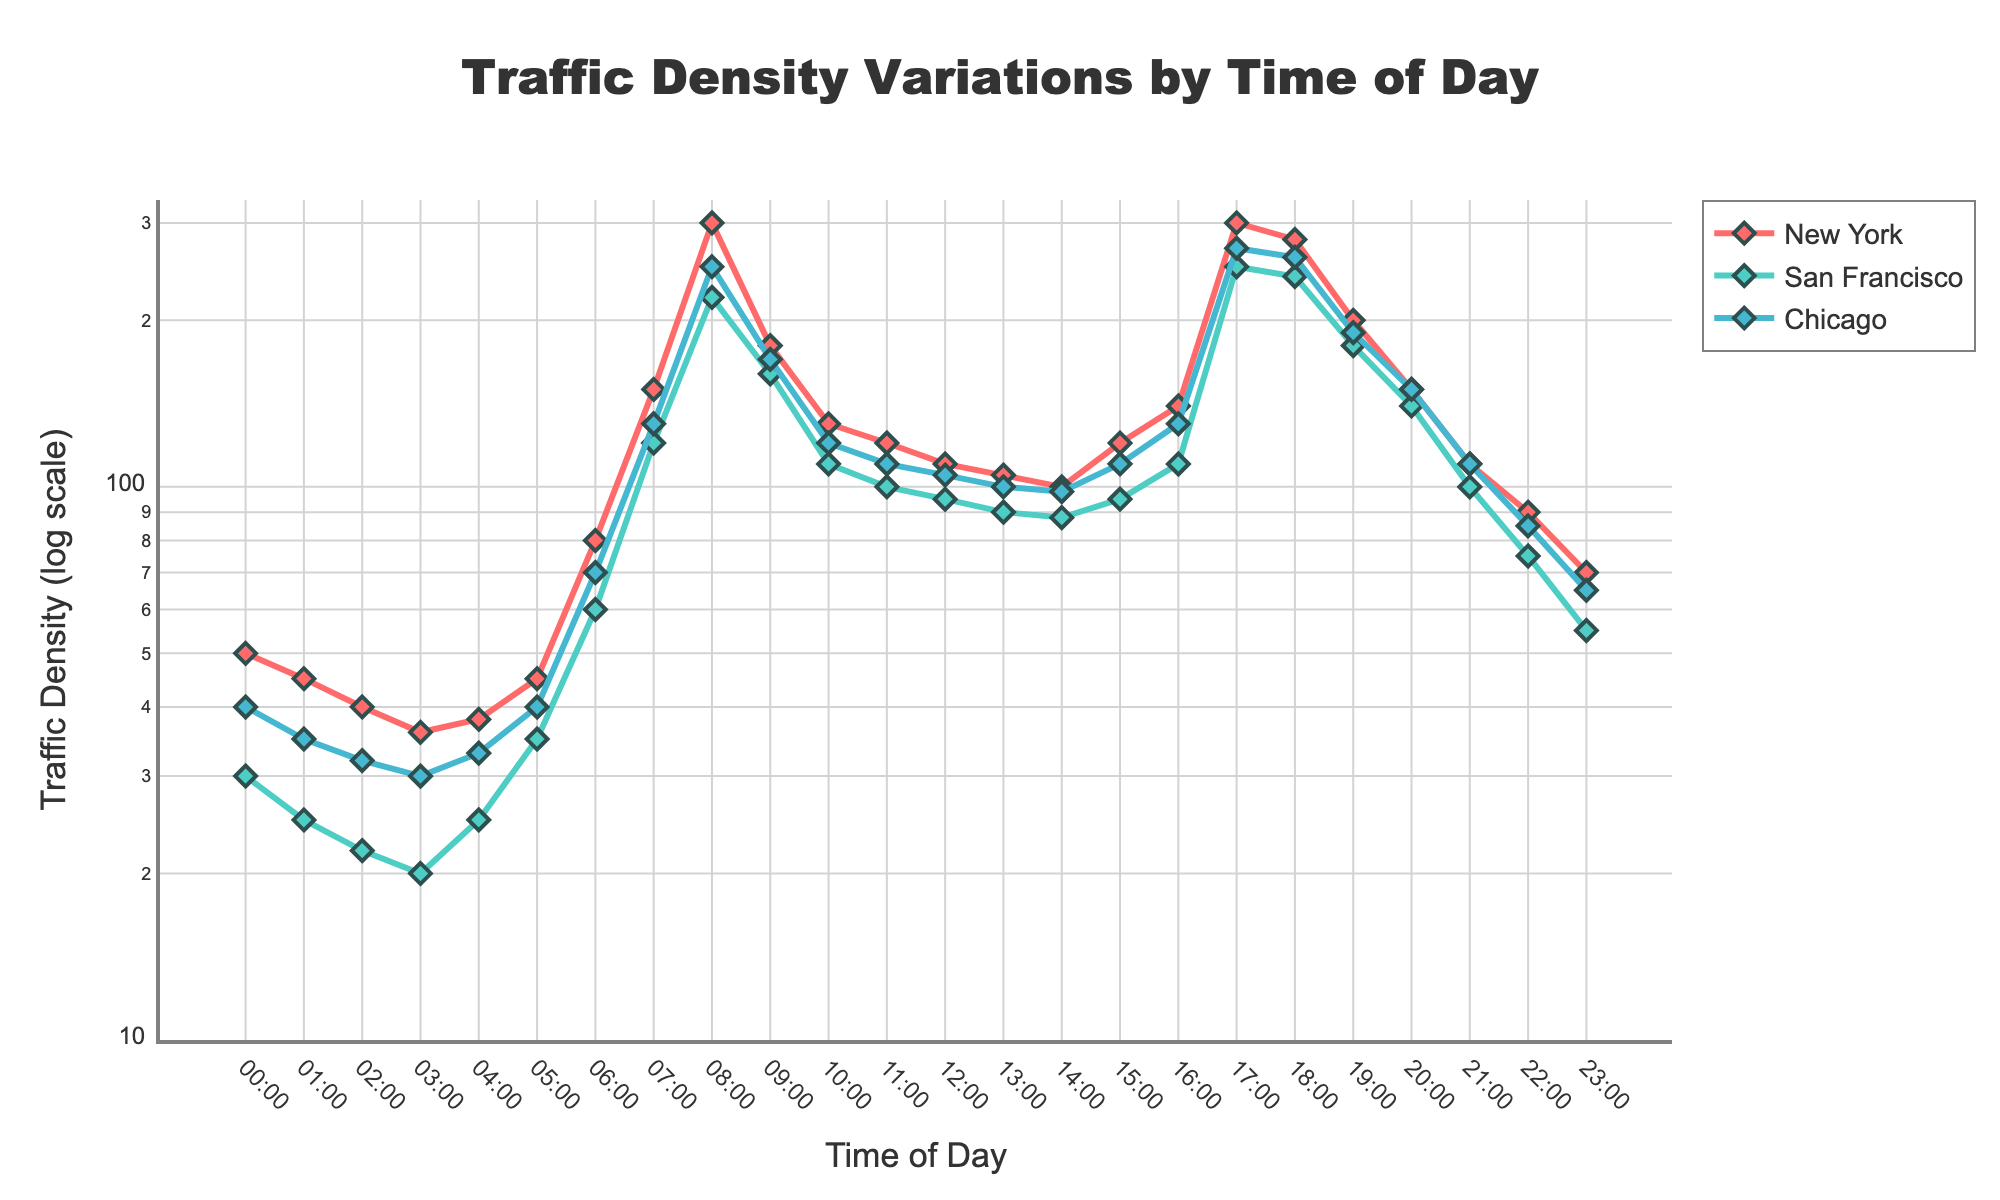What is the title of the plot? The title of the figure is displayed at the top-center of the plot in a larger font size. The title is bold and clearly states the main subject of the plot as 'Traffic Density Variations by Time of Day'.
Answer: Traffic Density Variations by Time of Day What is indicated by the y-axis title? The y-axis title is displayed vertically along the left side of the plot. It reads 'Traffic Density (log scale)', indicating that the traffic density values are plotted on a logarithmic scale.
Answer: Traffic Density (log scale) At what time of day is the traffic density the highest in New York? By referring to the line representing New York in the graph, we observe the peak at 08:00 and 17:00 marked by the highest density points. Both peak times show the highest traffic density, evidenced by the sharp upward trend in the plot.
Answer: 08:00 and 17:00 Which city shows the lowest traffic density at 03:00? At 03:00, compare the points on the plot for the three cities. San Francisco displays the lowest value among all at this time.
Answer: San Francisco When does San Francisco experience its highest traffic density? Following the line for San Francisco, the peak traffic density is evident at 17:00. This sharp increase indicates the peak traffic time.
Answer: 17:00 Compare the traffic density trends between New York and Chicago during the early morning hours (00:00-06:00). Between 00:00-06:00, both lines show gradual increases. However, New York experiences a more significant increase after 05:00, while Chicago shows a more steady rise.
Answer: New York has a steeper rise after 05:00, Chicago is steadier Which city has a more consistent traffic density during midday (10:00-14:00)? Observing the lines from 10:00 to 14:00, San Francisco and Chicago have relatively smaller fluctuations compared to New York. The traffic density values for San Francisco appear to be the most stable during this period.
Answer: San Francisco What is the approximate traffic density in Chicago at 18:00? Locate the data point for Chicago at 18:00 on the line plot, which lies slightly below 270. Complementing the image details, Chicago's traffic density can be approximated to around 260.
Answer: 260 How does the rush hour traffic density at 07:00 compare across the three cities? At 07:00, the plot's lines for three cities show the following values: New York at 150, San Francisco at 120, and Chicago at 130. Thus, New York has the highest density, followed by Chicago and then San Francisco.
Answer: New York > Chicago > San Francisco 